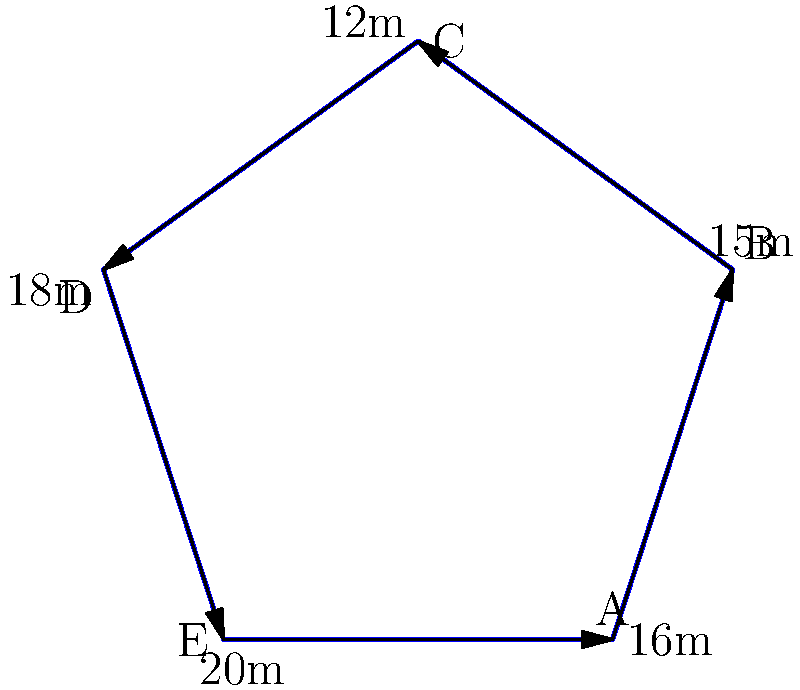A new multicultural student center is being designed on campus to promote diversity and inclusion. The center's floor plan is shaped like an irregular pentagon, as shown in the diagram. If the perimeter of the center needs to be fenced for security purposes, how many meters of fencing will be required? To find the perimeter of the multicultural student center, we need to add up the lengths of all sides of the pentagon. Let's go through this step-by-step:

1. Identify the length of each side:
   - Side AB: 15 meters
   - Side BC: 12 meters
   - Side CD: 18 meters
   - Side DE: 20 meters
   - Side EA: 16 meters

2. Add up all the side lengths:
   $$ \text{Perimeter} = AB + BC + CD + DE + EA $$
   $$ \text{Perimeter} = 15 + 12 + 18 + 20 + 16 $$
   $$ \text{Perimeter} = 81 \text{ meters} $$

Therefore, 81 meters of fencing will be required to enclose the entire multicultural student center.
Answer: 81 meters 